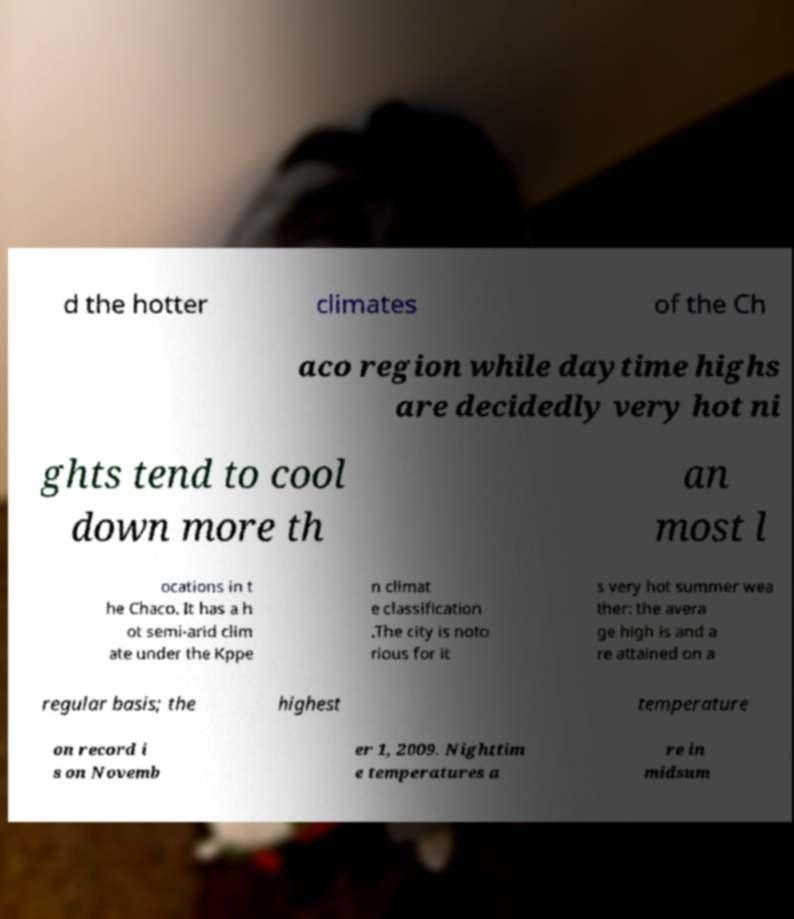Please identify and transcribe the text found in this image. d the hotter climates of the Ch aco region while daytime highs are decidedly very hot ni ghts tend to cool down more th an most l ocations in t he Chaco. It has a h ot semi-arid clim ate under the Kppe n climat e classification .The city is noto rious for it s very hot summer wea ther: the avera ge high is and a re attained on a regular basis; the highest temperature on record i s on Novemb er 1, 2009. Nighttim e temperatures a re in midsum 